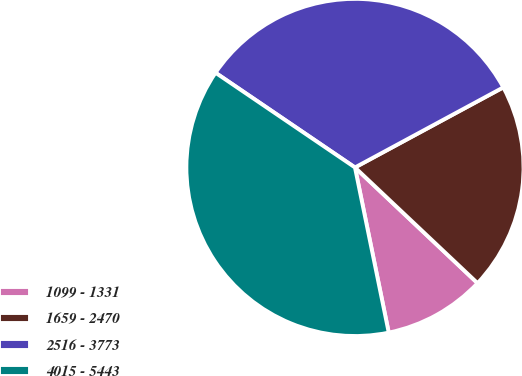<chart> <loc_0><loc_0><loc_500><loc_500><pie_chart><fcel>1099 - 1331<fcel>1659 - 2470<fcel>2516 - 3773<fcel>4015 - 5443<nl><fcel>9.75%<fcel>19.92%<fcel>32.63%<fcel>37.71%<nl></chart> 